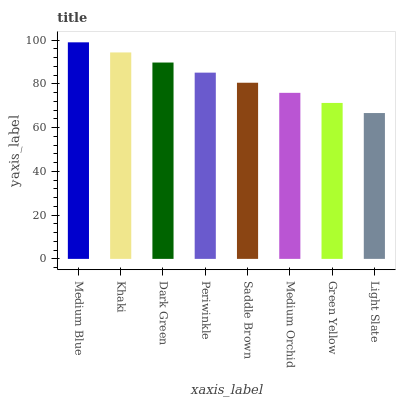Is Khaki the minimum?
Answer yes or no. No. Is Khaki the maximum?
Answer yes or no. No. Is Medium Blue greater than Khaki?
Answer yes or no. Yes. Is Khaki less than Medium Blue?
Answer yes or no. Yes. Is Khaki greater than Medium Blue?
Answer yes or no. No. Is Medium Blue less than Khaki?
Answer yes or no. No. Is Periwinkle the high median?
Answer yes or no. Yes. Is Saddle Brown the low median?
Answer yes or no. Yes. Is Medium Blue the high median?
Answer yes or no. No. Is Medium Blue the low median?
Answer yes or no. No. 